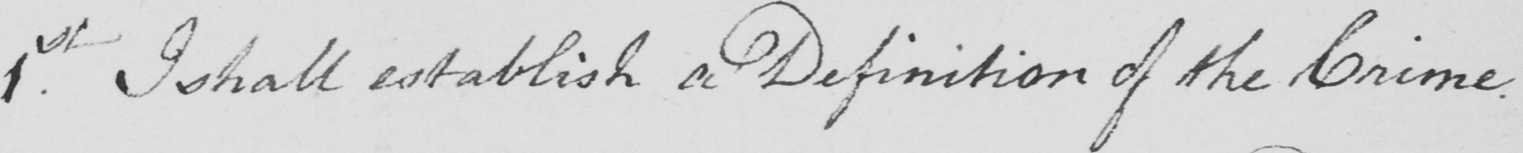Can you tell me what this handwritten text says? 1st . I shall establish a Definition of the Crime . 